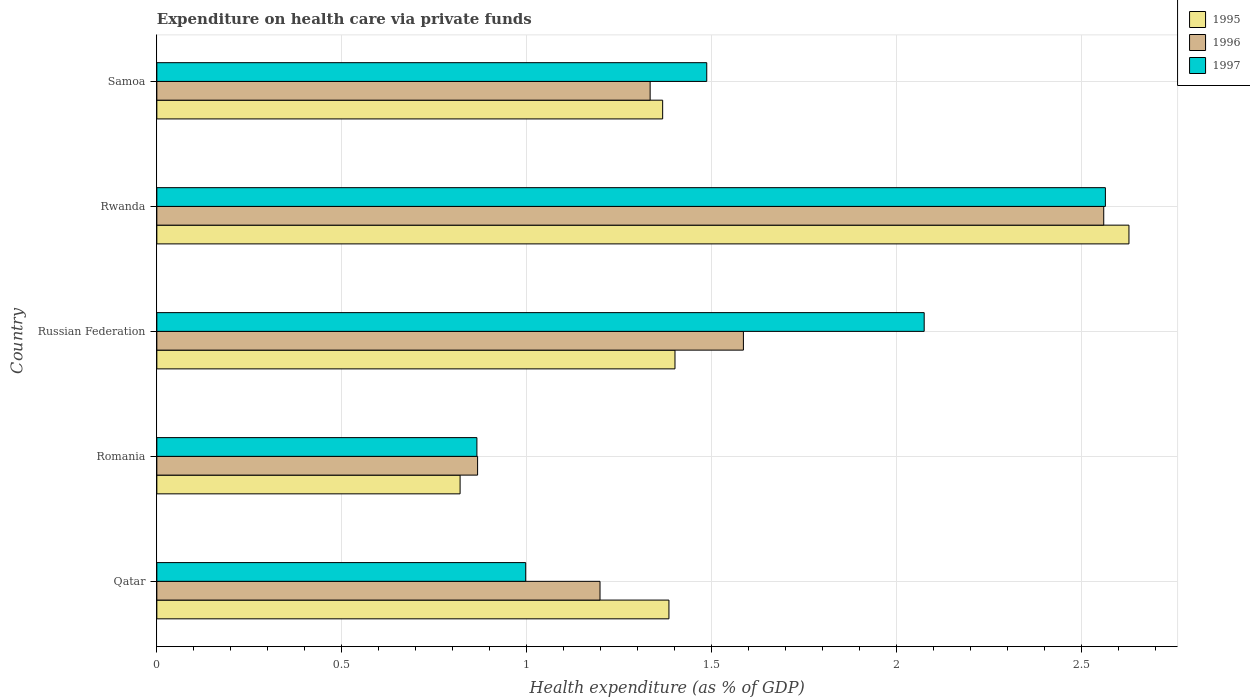How many different coloured bars are there?
Make the answer very short. 3. Are the number of bars on each tick of the Y-axis equal?
Ensure brevity in your answer.  Yes. How many bars are there on the 1st tick from the top?
Keep it short and to the point. 3. How many bars are there on the 1st tick from the bottom?
Provide a succinct answer. 3. What is the label of the 5th group of bars from the top?
Ensure brevity in your answer.  Qatar. In how many cases, is the number of bars for a given country not equal to the number of legend labels?
Your response must be concise. 0. What is the expenditure made on health care in 1997 in Rwanda?
Ensure brevity in your answer.  2.56. Across all countries, what is the maximum expenditure made on health care in 1996?
Ensure brevity in your answer.  2.56. Across all countries, what is the minimum expenditure made on health care in 1997?
Offer a terse response. 0.87. In which country was the expenditure made on health care in 1996 maximum?
Your answer should be compact. Rwanda. In which country was the expenditure made on health care in 1995 minimum?
Ensure brevity in your answer.  Romania. What is the total expenditure made on health care in 1996 in the graph?
Offer a very short reply. 7.54. What is the difference between the expenditure made on health care in 1996 in Qatar and that in Romania?
Ensure brevity in your answer.  0.33. What is the difference between the expenditure made on health care in 1995 in Romania and the expenditure made on health care in 1997 in Russian Federation?
Provide a succinct answer. -1.25. What is the average expenditure made on health care in 1996 per country?
Make the answer very short. 1.51. What is the difference between the expenditure made on health care in 1997 and expenditure made on health care in 1995 in Rwanda?
Your answer should be very brief. -0.06. What is the ratio of the expenditure made on health care in 1996 in Qatar to that in Samoa?
Give a very brief answer. 0.9. Is the difference between the expenditure made on health care in 1997 in Romania and Samoa greater than the difference between the expenditure made on health care in 1995 in Romania and Samoa?
Your answer should be compact. No. What is the difference between the highest and the second highest expenditure made on health care in 1996?
Your answer should be very brief. 0.97. What is the difference between the highest and the lowest expenditure made on health care in 1995?
Provide a succinct answer. 1.81. What does the 1st bar from the bottom in Russian Federation represents?
Provide a short and direct response. 1995. Is it the case that in every country, the sum of the expenditure made on health care in 1995 and expenditure made on health care in 1997 is greater than the expenditure made on health care in 1996?
Offer a very short reply. Yes. How many bars are there?
Provide a short and direct response. 15. How many countries are there in the graph?
Keep it short and to the point. 5. Are the values on the major ticks of X-axis written in scientific E-notation?
Offer a very short reply. No. Does the graph contain grids?
Offer a terse response. Yes. How many legend labels are there?
Give a very brief answer. 3. What is the title of the graph?
Offer a very short reply. Expenditure on health care via private funds. What is the label or title of the X-axis?
Make the answer very short. Health expenditure (as % of GDP). What is the Health expenditure (as % of GDP) of 1995 in Qatar?
Your answer should be compact. 1.38. What is the Health expenditure (as % of GDP) of 1996 in Qatar?
Offer a terse response. 1.2. What is the Health expenditure (as % of GDP) of 1997 in Qatar?
Give a very brief answer. 1. What is the Health expenditure (as % of GDP) of 1995 in Romania?
Keep it short and to the point. 0.82. What is the Health expenditure (as % of GDP) in 1996 in Romania?
Provide a succinct answer. 0.87. What is the Health expenditure (as % of GDP) in 1997 in Romania?
Provide a short and direct response. 0.87. What is the Health expenditure (as % of GDP) of 1995 in Russian Federation?
Give a very brief answer. 1.4. What is the Health expenditure (as % of GDP) of 1996 in Russian Federation?
Provide a succinct answer. 1.59. What is the Health expenditure (as % of GDP) of 1997 in Russian Federation?
Keep it short and to the point. 2.07. What is the Health expenditure (as % of GDP) of 1995 in Rwanda?
Make the answer very short. 2.63. What is the Health expenditure (as % of GDP) of 1996 in Rwanda?
Offer a terse response. 2.56. What is the Health expenditure (as % of GDP) of 1997 in Rwanda?
Your answer should be very brief. 2.56. What is the Health expenditure (as % of GDP) of 1995 in Samoa?
Make the answer very short. 1.37. What is the Health expenditure (as % of GDP) of 1996 in Samoa?
Offer a terse response. 1.33. What is the Health expenditure (as % of GDP) in 1997 in Samoa?
Provide a succinct answer. 1.49. Across all countries, what is the maximum Health expenditure (as % of GDP) in 1995?
Ensure brevity in your answer.  2.63. Across all countries, what is the maximum Health expenditure (as % of GDP) of 1996?
Make the answer very short. 2.56. Across all countries, what is the maximum Health expenditure (as % of GDP) of 1997?
Make the answer very short. 2.56. Across all countries, what is the minimum Health expenditure (as % of GDP) of 1995?
Give a very brief answer. 0.82. Across all countries, what is the minimum Health expenditure (as % of GDP) in 1996?
Keep it short and to the point. 0.87. Across all countries, what is the minimum Health expenditure (as % of GDP) of 1997?
Your response must be concise. 0.87. What is the total Health expenditure (as % of GDP) of 1995 in the graph?
Keep it short and to the point. 7.6. What is the total Health expenditure (as % of GDP) of 1996 in the graph?
Your answer should be compact. 7.54. What is the total Health expenditure (as % of GDP) of 1997 in the graph?
Offer a terse response. 7.99. What is the difference between the Health expenditure (as % of GDP) in 1995 in Qatar and that in Romania?
Ensure brevity in your answer.  0.56. What is the difference between the Health expenditure (as % of GDP) of 1996 in Qatar and that in Romania?
Offer a very short reply. 0.33. What is the difference between the Health expenditure (as % of GDP) in 1997 in Qatar and that in Romania?
Keep it short and to the point. 0.13. What is the difference between the Health expenditure (as % of GDP) in 1995 in Qatar and that in Russian Federation?
Provide a succinct answer. -0.02. What is the difference between the Health expenditure (as % of GDP) in 1996 in Qatar and that in Russian Federation?
Your answer should be very brief. -0.39. What is the difference between the Health expenditure (as % of GDP) of 1997 in Qatar and that in Russian Federation?
Make the answer very short. -1.08. What is the difference between the Health expenditure (as % of GDP) in 1995 in Qatar and that in Rwanda?
Give a very brief answer. -1.24. What is the difference between the Health expenditure (as % of GDP) of 1996 in Qatar and that in Rwanda?
Offer a terse response. -1.36. What is the difference between the Health expenditure (as % of GDP) in 1997 in Qatar and that in Rwanda?
Give a very brief answer. -1.57. What is the difference between the Health expenditure (as % of GDP) of 1995 in Qatar and that in Samoa?
Offer a terse response. 0.02. What is the difference between the Health expenditure (as % of GDP) of 1996 in Qatar and that in Samoa?
Provide a short and direct response. -0.14. What is the difference between the Health expenditure (as % of GDP) in 1997 in Qatar and that in Samoa?
Keep it short and to the point. -0.49. What is the difference between the Health expenditure (as % of GDP) of 1995 in Romania and that in Russian Federation?
Make the answer very short. -0.58. What is the difference between the Health expenditure (as % of GDP) of 1996 in Romania and that in Russian Federation?
Your answer should be compact. -0.72. What is the difference between the Health expenditure (as % of GDP) of 1997 in Romania and that in Russian Federation?
Provide a short and direct response. -1.21. What is the difference between the Health expenditure (as % of GDP) in 1995 in Romania and that in Rwanda?
Provide a succinct answer. -1.81. What is the difference between the Health expenditure (as % of GDP) of 1996 in Romania and that in Rwanda?
Your response must be concise. -1.69. What is the difference between the Health expenditure (as % of GDP) in 1997 in Romania and that in Rwanda?
Make the answer very short. -1.7. What is the difference between the Health expenditure (as % of GDP) of 1995 in Romania and that in Samoa?
Provide a short and direct response. -0.55. What is the difference between the Health expenditure (as % of GDP) of 1996 in Romania and that in Samoa?
Provide a succinct answer. -0.47. What is the difference between the Health expenditure (as % of GDP) in 1997 in Romania and that in Samoa?
Provide a succinct answer. -0.62. What is the difference between the Health expenditure (as % of GDP) of 1995 in Russian Federation and that in Rwanda?
Offer a terse response. -1.23. What is the difference between the Health expenditure (as % of GDP) in 1996 in Russian Federation and that in Rwanda?
Your answer should be very brief. -0.97. What is the difference between the Health expenditure (as % of GDP) of 1997 in Russian Federation and that in Rwanda?
Ensure brevity in your answer.  -0.49. What is the difference between the Health expenditure (as % of GDP) of 1996 in Russian Federation and that in Samoa?
Offer a very short reply. 0.25. What is the difference between the Health expenditure (as % of GDP) in 1997 in Russian Federation and that in Samoa?
Your answer should be very brief. 0.59. What is the difference between the Health expenditure (as % of GDP) in 1995 in Rwanda and that in Samoa?
Make the answer very short. 1.26. What is the difference between the Health expenditure (as % of GDP) in 1996 in Rwanda and that in Samoa?
Provide a short and direct response. 1.23. What is the difference between the Health expenditure (as % of GDP) of 1997 in Rwanda and that in Samoa?
Provide a succinct answer. 1.08. What is the difference between the Health expenditure (as % of GDP) of 1995 in Qatar and the Health expenditure (as % of GDP) of 1996 in Romania?
Give a very brief answer. 0.52. What is the difference between the Health expenditure (as % of GDP) of 1995 in Qatar and the Health expenditure (as % of GDP) of 1997 in Romania?
Provide a succinct answer. 0.52. What is the difference between the Health expenditure (as % of GDP) of 1996 in Qatar and the Health expenditure (as % of GDP) of 1997 in Romania?
Your answer should be compact. 0.33. What is the difference between the Health expenditure (as % of GDP) of 1995 in Qatar and the Health expenditure (as % of GDP) of 1996 in Russian Federation?
Your answer should be compact. -0.2. What is the difference between the Health expenditure (as % of GDP) in 1995 in Qatar and the Health expenditure (as % of GDP) in 1997 in Russian Federation?
Ensure brevity in your answer.  -0.69. What is the difference between the Health expenditure (as % of GDP) of 1996 in Qatar and the Health expenditure (as % of GDP) of 1997 in Russian Federation?
Provide a short and direct response. -0.88. What is the difference between the Health expenditure (as % of GDP) in 1995 in Qatar and the Health expenditure (as % of GDP) in 1996 in Rwanda?
Make the answer very short. -1.18. What is the difference between the Health expenditure (as % of GDP) of 1995 in Qatar and the Health expenditure (as % of GDP) of 1997 in Rwanda?
Your answer should be very brief. -1.18. What is the difference between the Health expenditure (as % of GDP) of 1996 in Qatar and the Health expenditure (as % of GDP) of 1997 in Rwanda?
Offer a terse response. -1.37. What is the difference between the Health expenditure (as % of GDP) of 1995 in Qatar and the Health expenditure (as % of GDP) of 1996 in Samoa?
Your answer should be compact. 0.05. What is the difference between the Health expenditure (as % of GDP) in 1995 in Qatar and the Health expenditure (as % of GDP) in 1997 in Samoa?
Your answer should be very brief. -0.1. What is the difference between the Health expenditure (as % of GDP) in 1996 in Qatar and the Health expenditure (as % of GDP) in 1997 in Samoa?
Keep it short and to the point. -0.29. What is the difference between the Health expenditure (as % of GDP) of 1995 in Romania and the Health expenditure (as % of GDP) of 1996 in Russian Federation?
Provide a short and direct response. -0.77. What is the difference between the Health expenditure (as % of GDP) of 1995 in Romania and the Health expenditure (as % of GDP) of 1997 in Russian Federation?
Your answer should be compact. -1.25. What is the difference between the Health expenditure (as % of GDP) in 1996 in Romania and the Health expenditure (as % of GDP) in 1997 in Russian Federation?
Offer a very short reply. -1.21. What is the difference between the Health expenditure (as % of GDP) in 1995 in Romania and the Health expenditure (as % of GDP) in 1996 in Rwanda?
Make the answer very short. -1.74. What is the difference between the Health expenditure (as % of GDP) of 1995 in Romania and the Health expenditure (as % of GDP) of 1997 in Rwanda?
Ensure brevity in your answer.  -1.74. What is the difference between the Health expenditure (as % of GDP) in 1996 in Romania and the Health expenditure (as % of GDP) in 1997 in Rwanda?
Offer a very short reply. -1.7. What is the difference between the Health expenditure (as % of GDP) in 1995 in Romania and the Health expenditure (as % of GDP) in 1996 in Samoa?
Provide a succinct answer. -0.51. What is the difference between the Health expenditure (as % of GDP) of 1995 in Romania and the Health expenditure (as % of GDP) of 1997 in Samoa?
Provide a succinct answer. -0.67. What is the difference between the Health expenditure (as % of GDP) of 1996 in Romania and the Health expenditure (as % of GDP) of 1997 in Samoa?
Provide a short and direct response. -0.62. What is the difference between the Health expenditure (as % of GDP) in 1995 in Russian Federation and the Health expenditure (as % of GDP) in 1996 in Rwanda?
Your response must be concise. -1.16. What is the difference between the Health expenditure (as % of GDP) in 1995 in Russian Federation and the Health expenditure (as % of GDP) in 1997 in Rwanda?
Offer a very short reply. -1.16. What is the difference between the Health expenditure (as % of GDP) of 1996 in Russian Federation and the Health expenditure (as % of GDP) of 1997 in Rwanda?
Offer a very short reply. -0.98. What is the difference between the Health expenditure (as % of GDP) of 1995 in Russian Federation and the Health expenditure (as % of GDP) of 1996 in Samoa?
Keep it short and to the point. 0.07. What is the difference between the Health expenditure (as % of GDP) in 1995 in Russian Federation and the Health expenditure (as % of GDP) in 1997 in Samoa?
Ensure brevity in your answer.  -0.09. What is the difference between the Health expenditure (as % of GDP) of 1996 in Russian Federation and the Health expenditure (as % of GDP) of 1997 in Samoa?
Provide a short and direct response. 0.1. What is the difference between the Health expenditure (as % of GDP) of 1995 in Rwanda and the Health expenditure (as % of GDP) of 1996 in Samoa?
Your answer should be compact. 1.29. What is the difference between the Health expenditure (as % of GDP) in 1995 in Rwanda and the Health expenditure (as % of GDP) in 1997 in Samoa?
Offer a very short reply. 1.14. What is the difference between the Health expenditure (as % of GDP) of 1996 in Rwanda and the Health expenditure (as % of GDP) of 1997 in Samoa?
Your response must be concise. 1.07. What is the average Health expenditure (as % of GDP) in 1995 per country?
Provide a succinct answer. 1.52. What is the average Health expenditure (as % of GDP) of 1996 per country?
Your answer should be compact. 1.51. What is the average Health expenditure (as % of GDP) of 1997 per country?
Your answer should be compact. 1.6. What is the difference between the Health expenditure (as % of GDP) of 1995 and Health expenditure (as % of GDP) of 1996 in Qatar?
Give a very brief answer. 0.19. What is the difference between the Health expenditure (as % of GDP) in 1995 and Health expenditure (as % of GDP) in 1997 in Qatar?
Your answer should be compact. 0.39. What is the difference between the Health expenditure (as % of GDP) in 1996 and Health expenditure (as % of GDP) in 1997 in Qatar?
Your response must be concise. 0.2. What is the difference between the Health expenditure (as % of GDP) in 1995 and Health expenditure (as % of GDP) in 1996 in Romania?
Provide a short and direct response. -0.05. What is the difference between the Health expenditure (as % of GDP) of 1995 and Health expenditure (as % of GDP) of 1997 in Romania?
Your response must be concise. -0.05. What is the difference between the Health expenditure (as % of GDP) of 1996 and Health expenditure (as % of GDP) of 1997 in Romania?
Your answer should be very brief. 0. What is the difference between the Health expenditure (as % of GDP) in 1995 and Health expenditure (as % of GDP) in 1996 in Russian Federation?
Make the answer very short. -0.18. What is the difference between the Health expenditure (as % of GDP) in 1995 and Health expenditure (as % of GDP) in 1997 in Russian Federation?
Provide a succinct answer. -0.67. What is the difference between the Health expenditure (as % of GDP) in 1996 and Health expenditure (as % of GDP) in 1997 in Russian Federation?
Your answer should be very brief. -0.49. What is the difference between the Health expenditure (as % of GDP) of 1995 and Health expenditure (as % of GDP) of 1996 in Rwanda?
Offer a very short reply. 0.07. What is the difference between the Health expenditure (as % of GDP) of 1995 and Health expenditure (as % of GDP) of 1997 in Rwanda?
Make the answer very short. 0.06. What is the difference between the Health expenditure (as % of GDP) in 1996 and Health expenditure (as % of GDP) in 1997 in Rwanda?
Provide a succinct answer. -0. What is the difference between the Health expenditure (as % of GDP) in 1995 and Health expenditure (as % of GDP) in 1996 in Samoa?
Provide a succinct answer. 0.03. What is the difference between the Health expenditure (as % of GDP) of 1995 and Health expenditure (as % of GDP) of 1997 in Samoa?
Give a very brief answer. -0.12. What is the difference between the Health expenditure (as % of GDP) in 1996 and Health expenditure (as % of GDP) in 1997 in Samoa?
Your answer should be very brief. -0.15. What is the ratio of the Health expenditure (as % of GDP) in 1995 in Qatar to that in Romania?
Keep it short and to the point. 1.69. What is the ratio of the Health expenditure (as % of GDP) of 1996 in Qatar to that in Romania?
Your answer should be very brief. 1.38. What is the ratio of the Health expenditure (as % of GDP) in 1997 in Qatar to that in Romania?
Your answer should be compact. 1.15. What is the ratio of the Health expenditure (as % of GDP) in 1995 in Qatar to that in Russian Federation?
Make the answer very short. 0.99. What is the ratio of the Health expenditure (as % of GDP) in 1996 in Qatar to that in Russian Federation?
Ensure brevity in your answer.  0.76. What is the ratio of the Health expenditure (as % of GDP) in 1997 in Qatar to that in Russian Federation?
Provide a short and direct response. 0.48. What is the ratio of the Health expenditure (as % of GDP) in 1995 in Qatar to that in Rwanda?
Give a very brief answer. 0.53. What is the ratio of the Health expenditure (as % of GDP) of 1996 in Qatar to that in Rwanda?
Provide a short and direct response. 0.47. What is the ratio of the Health expenditure (as % of GDP) of 1997 in Qatar to that in Rwanda?
Offer a terse response. 0.39. What is the ratio of the Health expenditure (as % of GDP) in 1995 in Qatar to that in Samoa?
Offer a terse response. 1.01. What is the ratio of the Health expenditure (as % of GDP) in 1996 in Qatar to that in Samoa?
Offer a very short reply. 0.9. What is the ratio of the Health expenditure (as % of GDP) of 1997 in Qatar to that in Samoa?
Your answer should be compact. 0.67. What is the ratio of the Health expenditure (as % of GDP) in 1995 in Romania to that in Russian Federation?
Keep it short and to the point. 0.59. What is the ratio of the Health expenditure (as % of GDP) of 1996 in Romania to that in Russian Federation?
Keep it short and to the point. 0.55. What is the ratio of the Health expenditure (as % of GDP) in 1997 in Romania to that in Russian Federation?
Offer a terse response. 0.42. What is the ratio of the Health expenditure (as % of GDP) of 1995 in Romania to that in Rwanda?
Provide a succinct answer. 0.31. What is the ratio of the Health expenditure (as % of GDP) of 1996 in Romania to that in Rwanda?
Keep it short and to the point. 0.34. What is the ratio of the Health expenditure (as % of GDP) in 1997 in Romania to that in Rwanda?
Keep it short and to the point. 0.34. What is the ratio of the Health expenditure (as % of GDP) of 1995 in Romania to that in Samoa?
Your answer should be compact. 0.6. What is the ratio of the Health expenditure (as % of GDP) of 1996 in Romania to that in Samoa?
Give a very brief answer. 0.65. What is the ratio of the Health expenditure (as % of GDP) in 1997 in Romania to that in Samoa?
Offer a terse response. 0.58. What is the ratio of the Health expenditure (as % of GDP) in 1995 in Russian Federation to that in Rwanda?
Provide a short and direct response. 0.53. What is the ratio of the Health expenditure (as % of GDP) in 1996 in Russian Federation to that in Rwanda?
Provide a short and direct response. 0.62. What is the ratio of the Health expenditure (as % of GDP) in 1997 in Russian Federation to that in Rwanda?
Provide a short and direct response. 0.81. What is the ratio of the Health expenditure (as % of GDP) of 1995 in Russian Federation to that in Samoa?
Make the answer very short. 1.02. What is the ratio of the Health expenditure (as % of GDP) of 1996 in Russian Federation to that in Samoa?
Your answer should be compact. 1.19. What is the ratio of the Health expenditure (as % of GDP) of 1997 in Russian Federation to that in Samoa?
Your answer should be compact. 1.4. What is the ratio of the Health expenditure (as % of GDP) in 1995 in Rwanda to that in Samoa?
Your response must be concise. 1.92. What is the ratio of the Health expenditure (as % of GDP) of 1996 in Rwanda to that in Samoa?
Your answer should be compact. 1.92. What is the ratio of the Health expenditure (as % of GDP) in 1997 in Rwanda to that in Samoa?
Keep it short and to the point. 1.72. What is the difference between the highest and the second highest Health expenditure (as % of GDP) of 1995?
Provide a succinct answer. 1.23. What is the difference between the highest and the second highest Health expenditure (as % of GDP) in 1996?
Your response must be concise. 0.97. What is the difference between the highest and the second highest Health expenditure (as % of GDP) of 1997?
Ensure brevity in your answer.  0.49. What is the difference between the highest and the lowest Health expenditure (as % of GDP) in 1995?
Provide a short and direct response. 1.81. What is the difference between the highest and the lowest Health expenditure (as % of GDP) of 1996?
Your response must be concise. 1.69. What is the difference between the highest and the lowest Health expenditure (as % of GDP) in 1997?
Give a very brief answer. 1.7. 